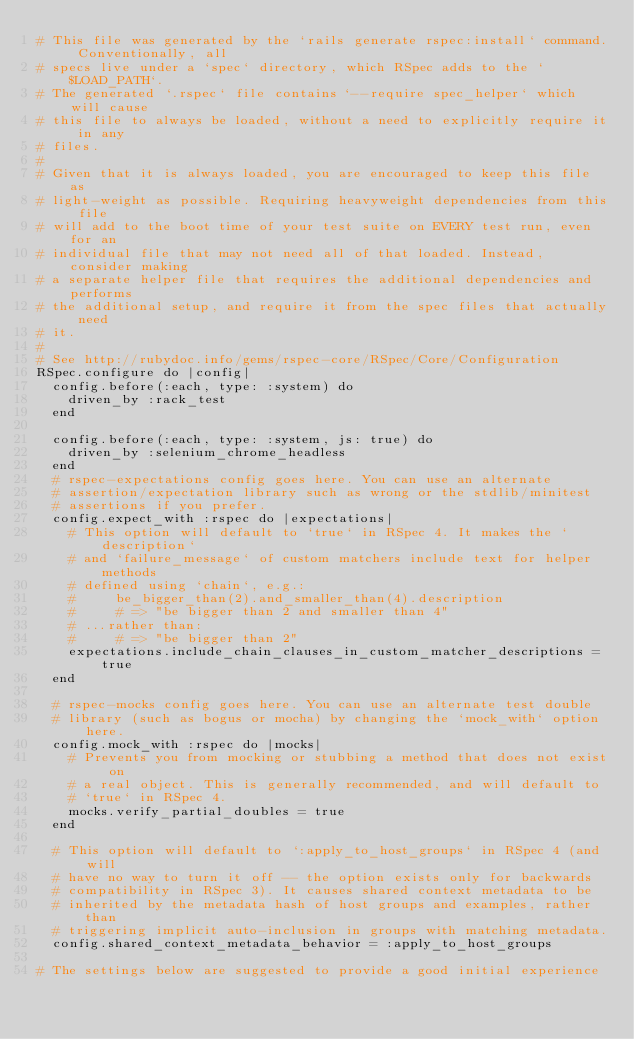Convert code to text. <code><loc_0><loc_0><loc_500><loc_500><_Ruby_># This file was generated by the `rails generate rspec:install` command. Conventionally, all
# specs live under a `spec` directory, which RSpec adds to the `$LOAD_PATH`.
# The generated `.rspec` file contains `--require spec_helper` which will cause
# this file to always be loaded, without a need to explicitly require it in any
# files.
#
# Given that it is always loaded, you are encouraged to keep this file as
# light-weight as possible. Requiring heavyweight dependencies from this file
# will add to the boot time of your test suite on EVERY test run, even for an
# individual file that may not need all of that loaded. Instead, consider making
# a separate helper file that requires the additional dependencies and performs
# the additional setup, and require it from the spec files that actually need
# it.
#
# See http://rubydoc.info/gems/rspec-core/RSpec/Core/Configuration
RSpec.configure do |config|
  config.before(:each, type: :system) do
    driven_by :rack_test
  end

  config.before(:each, type: :system, js: true) do
    driven_by :selenium_chrome_headless
  end
  # rspec-expectations config goes here. You can use an alternate
  # assertion/expectation library such as wrong or the stdlib/minitest
  # assertions if you prefer.
  config.expect_with :rspec do |expectations|
    # This option will default to `true` in RSpec 4. It makes the `description`
    # and `failure_message` of custom matchers include text for helper methods
    # defined using `chain`, e.g.:
    #     be_bigger_than(2).and_smaller_than(4).description
    #     # => "be bigger than 2 and smaller than 4"
    # ...rather than:
    #     # => "be bigger than 2"
    expectations.include_chain_clauses_in_custom_matcher_descriptions = true
  end

  # rspec-mocks config goes here. You can use an alternate test double
  # library (such as bogus or mocha) by changing the `mock_with` option here.
  config.mock_with :rspec do |mocks|
    # Prevents you from mocking or stubbing a method that does not exist on
    # a real object. This is generally recommended, and will default to
    # `true` in RSpec 4.
    mocks.verify_partial_doubles = true
  end

  # This option will default to `:apply_to_host_groups` in RSpec 4 (and will
  # have no way to turn it off -- the option exists only for backwards
  # compatibility in RSpec 3). It causes shared context metadata to be
  # inherited by the metadata hash of host groups and examples, rather than
  # triggering implicit auto-inclusion in groups with matching metadata.
  config.shared_context_metadata_behavior = :apply_to_host_groups

# The settings below are suggested to provide a good initial experience</code> 